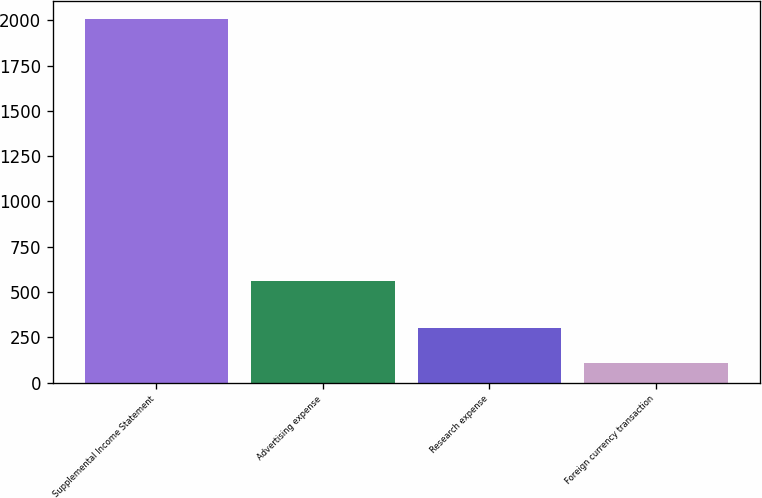Convert chart to OTSL. <chart><loc_0><loc_0><loc_500><loc_500><bar_chart><fcel>Supplemental Income Statement<fcel>Advertising expense<fcel>Research expense<fcel>Foreign currency transaction<nl><fcel>2009<fcel>559<fcel>301<fcel>110<nl></chart> 